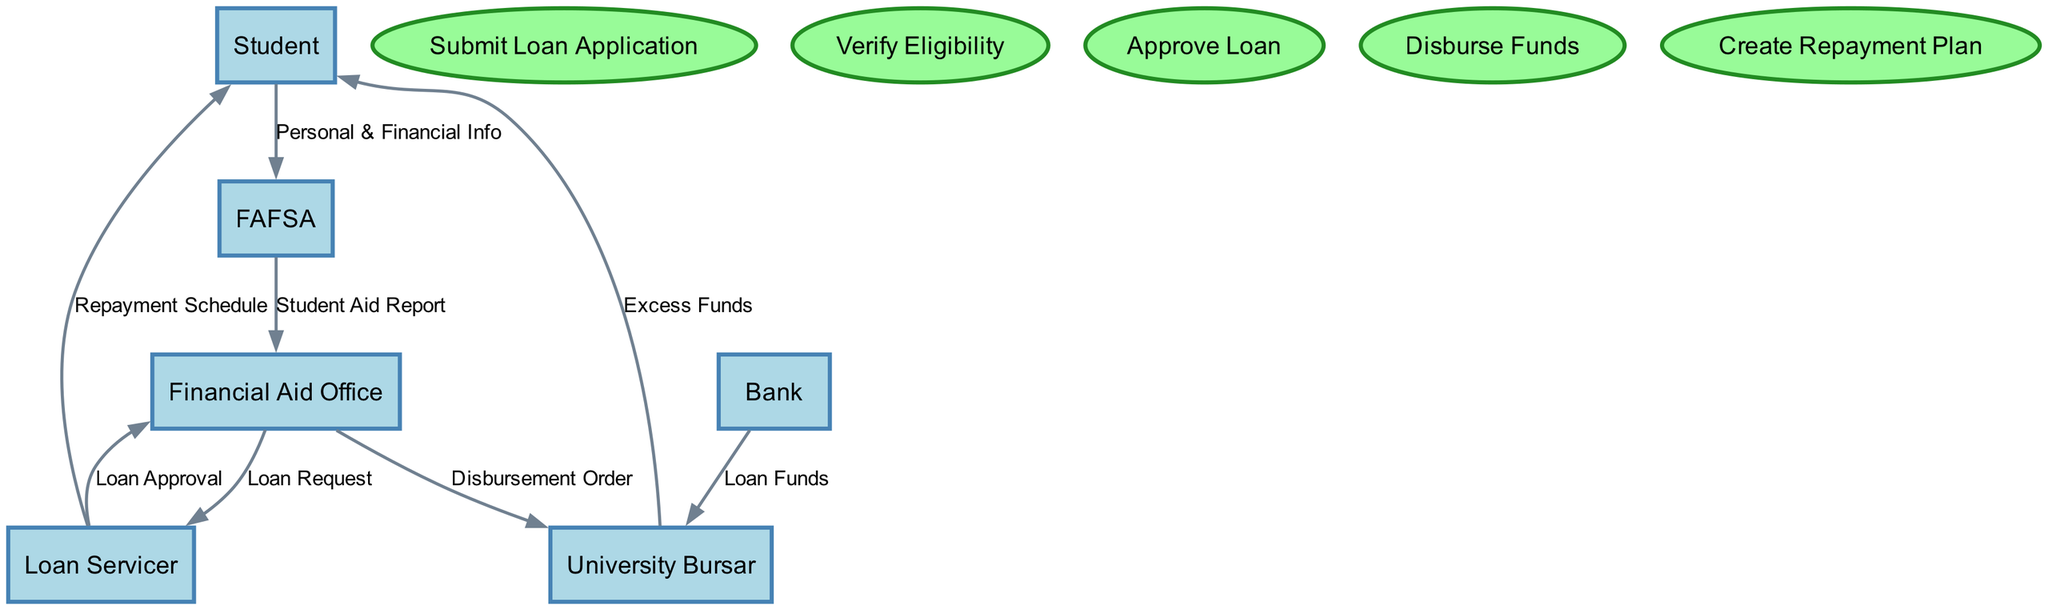What is the total number of entities in the diagram? There are six entities listed in the diagram: Student, Financial Aid Office, FAFSA, Loan Servicer, University Bursar, and Bank. Counting these gives a total of six.
Answer: 6 Which entities are involved in the disbursement of loan funds? The University Bursar and the Bank are the entities connected by the data flow labeled "Loan Funds." The University Bursar receives the loan funds from the Bank.
Answer: University Bursar, Bank What flows from the Student to the FAFSA? The data flow between Student and FAFSA is labeled "Personal & Financial Info," indicating that this information is submitted by the Student to the FAFSA.
Answer: Personal & Financial Info Who creates the repayment plan for the Student? The Loan Servicer is responsible for creating the repayment plan, as indicated by the data flow labeled "Repayment Schedule" that goes from Loan Servicer to Student.
Answer: Loan Servicer What does the Financial Aid Office send to the Loan Servicer? The Financial Aid Office sends a "Loan Request" to the Loan Servicer, as represented by the arrow showing the flow of this information.
Answer: Loan Request How does the flow of loan funds to the University Bursar occur? The flow of loan funds occurs from the Bank to the University Bursar, indicated by the data flow labeled "Loan Funds." This shows the source (Bank) and destination (University Bursar) of the funds.
Answer: Bank to University Bursar How many processes are there in the diagram? The diagram includes five processes: Submit Loan Application, Verify Eligibility, Approve Loan, Disburse Funds, and Create Repayment Plan. Counting these gives five distinct processes.
Answer: 5 What information does the University Bursar provide to the Student? The University Bursar provides "Excess Funds" to the Student, as indicated by the data flow that points from University Bursar to Student with that label.
Answer: Excess Funds What is the sequence of events starting from the submission of the loan application? The sequence begins with "Submit Loan Application," followed by "Verify Eligibility," then "Approve Loan," and finally "Disburse Funds." This establishes the flow of activities involved in processing the loan application.
Answer: Submit Loan Application, Verify Eligibility, Approve Loan, Disburse Funds 